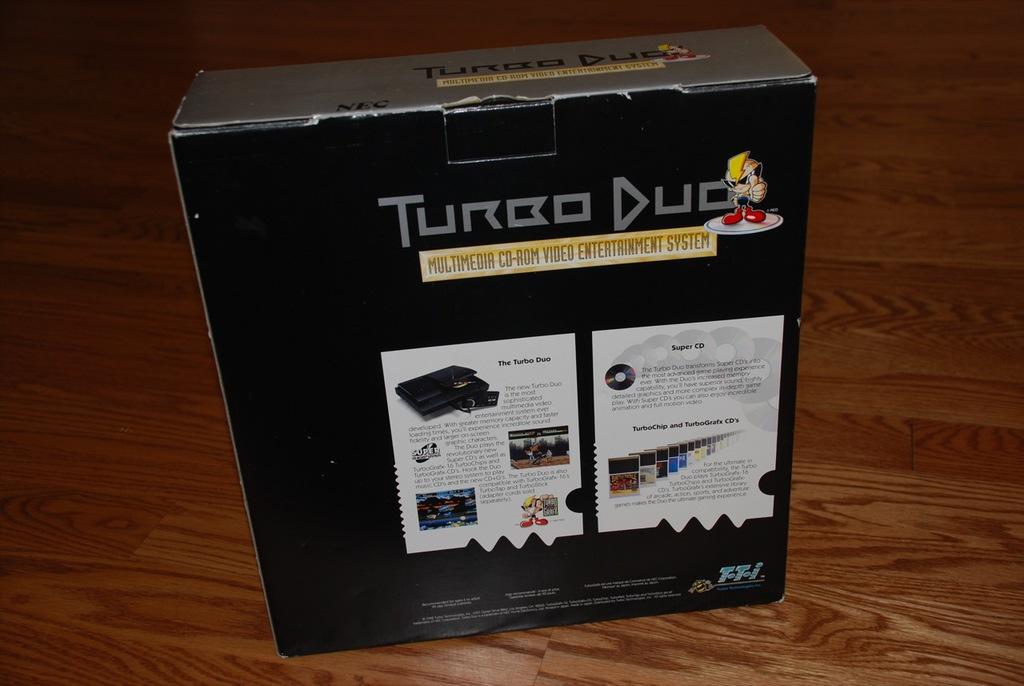What kind of system is this?
Your answer should be compact. Turbo duo. What brand of controller is this?
Ensure brevity in your answer.  Turbo duo. 